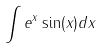<formula> <loc_0><loc_0><loc_500><loc_500>\int e ^ { x } \sin ( x ) d x</formula> 